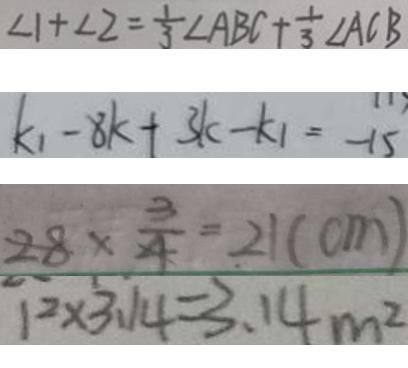<formula> <loc_0><loc_0><loc_500><loc_500>\angle 1 + \angle 2 = \frac { 1 } { 3 } \angle A B C + \frac { 1 } { 3 } \angle A C B 
 k _ { 1 } - 8 k + 3 k - k _ { 1 } = - 1 5 
 2 8 \times \frac { 3 } { 4 } = 2 1 ( c m ) 
 1 ^ { 2 } \times 3 . 1 4 = 3 . 1 4 m ^ { 2 }</formula> 